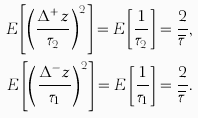<formula> <loc_0><loc_0><loc_500><loc_500>E \left [ \left ( \frac { \Delta ^ { + } z } { \tau _ { 2 } } \right ) ^ { 2 } \right ] = E \left [ \frac { 1 } { \tau _ { 2 } } \right ] = \frac { 2 } { \overline { \tau } } , \\ E \left [ \left ( \frac { \Delta ^ { - } z } { \tau _ { 1 } } \right ) ^ { 2 } \right ] = E \left [ \frac { 1 } { \tau _ { 1 } } \right ] = \frac { 2 } { \overline { \tau } } .</formula> 